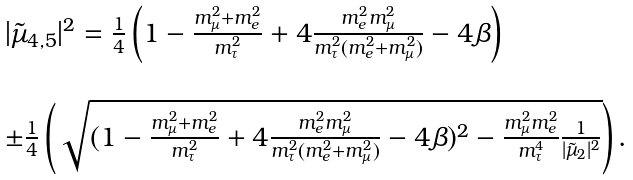<formula> <loc_0><loc_0><loc_500><loc_500>\begin{array} { l } | \tilde { \mu } _ { 4 , 5 } | ^ { 2 } = \frac { 1 } { 4 } \left ( 1 - \frac { m _ { \mu } ^ { 2 } + m _ { e } ^ { 2 } } { m _ { \tau } ^ { 2 } } + 4 \frac { m _ { e } ^ { 2 } m _ { \mu } ^ { 2 } } { m _ { \tau } ^ { 2 } ( m _ { e } ^ { 2 } + m _ { \mu } ^ { 2 } ) } - 4 \beta \right ) \\ \\ \pm \frac { 1 } { 4 } \left ( \sqrt { ( { 1 - \frac { m _ { \mu } ^ { 2 } + m _ { e } ^ { 2 } } { m _ { \tau } ^ { 2 } } + 4 \frac { m _ { e } ^ { 2 } m _ { \mu } ^ { 2 } } { m _ { \tau } ^ { 2 } ( m _ { e } ^ { 2 } + m _ { \mu } ^ { 2 } ) } - 4 \beta } ) ^ { 2 } - \frac { m _ { \mu } ^ { 2 } m _ { e } ^ { 2 } } { m _ { \tau } ^ { 4 } } \frac { 1 } { | \tilde { \mu } _ { 2 } | ^ { 2 } } } \right ) . \end{array}</formula> 